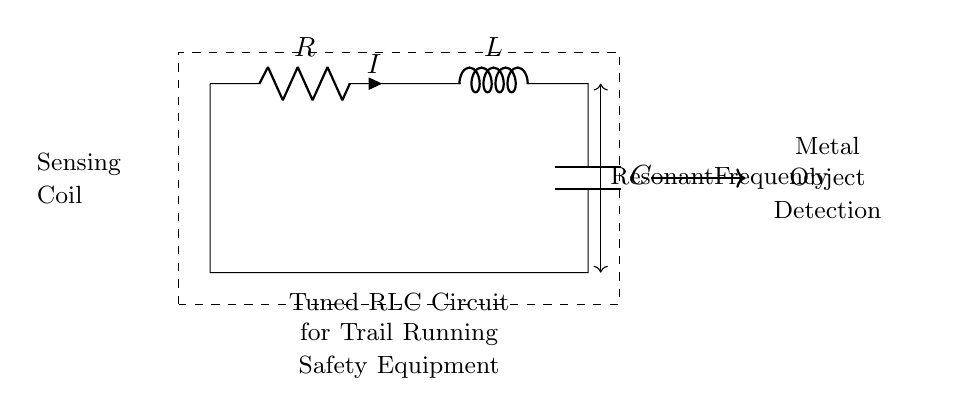What are the components in this circuit? The circuit diagram clearly shows three main components: a resistor (R), an inductor (L), and a capacitor (C). Each of these components serves a specific function in the tuned RLC circuit.
Answer: Resistor, Inductor, Capacitor What does the sensing coil refer to in this circuit? The term "Sensing Coil" in the diagram indicates the inductor (L), which is used to sense the presence of metal objects through its inductive properties. This inductor is crucial for the metal detection process in the application.
Answer: Inductor What is the purpose of the resonant frequency? The resonant frequency is a key feature of RLC circuits, where the inductive reactance and capacitive reactance are equal. This allows the circuit to have heightened sensitivity to specific frequencies, making it effective for metal detection.
Answer: Metal detection sensitivity How is the current flowing in the circuit? The current (I) flows from the power source through the resistor (R), then through the inductor (L), and finally through the capacitor (C) in a closed loop, which is indicated by the circuit connections.
Answer: Closed loop What type of circuit is this? This circuit is a tuned RLC circuit, characterized by its use of a resistor, inductor, and capacitor arranged in a way to allow resonance and detection of specific frequencies.
Answer: Tuned RLC circuit What would happen if the inductor was removed? If the inductor is removed from the circuit, it will drastically alter the behavior of the circuit, as there would be no inductive reactance present, preventing the circuit from resonating and thus failing in its metal detection capability.
Answer: Loss of metal detection functionality What effect does changing the capacitor value have on the circuit? Changing the value of the capacitor alters the resonant frequency of the circuit. A larger capacitor increases the capacitance, which lowers the resonant frequency, whereas a smaller capacitor can raise the resonant frequency, thus affecting sensitivity to metal detection.
Answer: Alters resonant frequency 